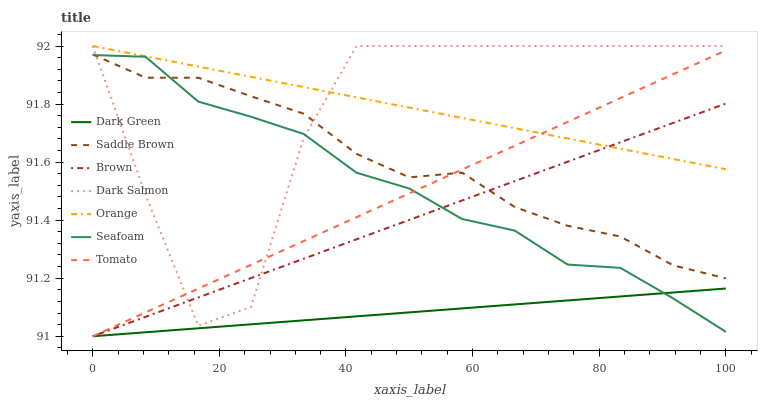Does Dark Green have the minimum area under the curve?
Answer yes or no. Yes. Does Orange have the maximum area under the curve?
Answer yes or no. Yes. Does Brown have the minimum area under the curve?
Answer yes or no. No. Does Brown have the maximum area under the curve?
Answer yes or no. No. Is Dark Green the smoothest?
Answer yes or no. Yes. Is Dark Salmon the roughest?
Answer yes or no. Yes. Is Brown the smoothest?
Answer yes or no. No. Is Brown the roughest?
Answer yes or no. No. Does Tomato have the lowest value?
Answer yes or no. Yes. Does Seafoam have the lowest value?
Answer yes or no. No. Does Orange have the highest value?
Answer yes or no. Yes. Does Brown have the highest value?
Answer yes or no. No. Is Dark Green less than Saddle Brown?
Answer yes or no. Yes. Is Dark Salmon greater than Dark Green?
Answer yes or no. Yes. Does Saddle Brown intersect Brown?
Answer yes or no. Yes. Is Saddle Brown less than Brown?
Answer yes or no. No. Is Saddle Brown greater than Brown?
Answer yes or no. No. Does Dark Green intersect Saddle Brown?
Answer yes or no. No. 